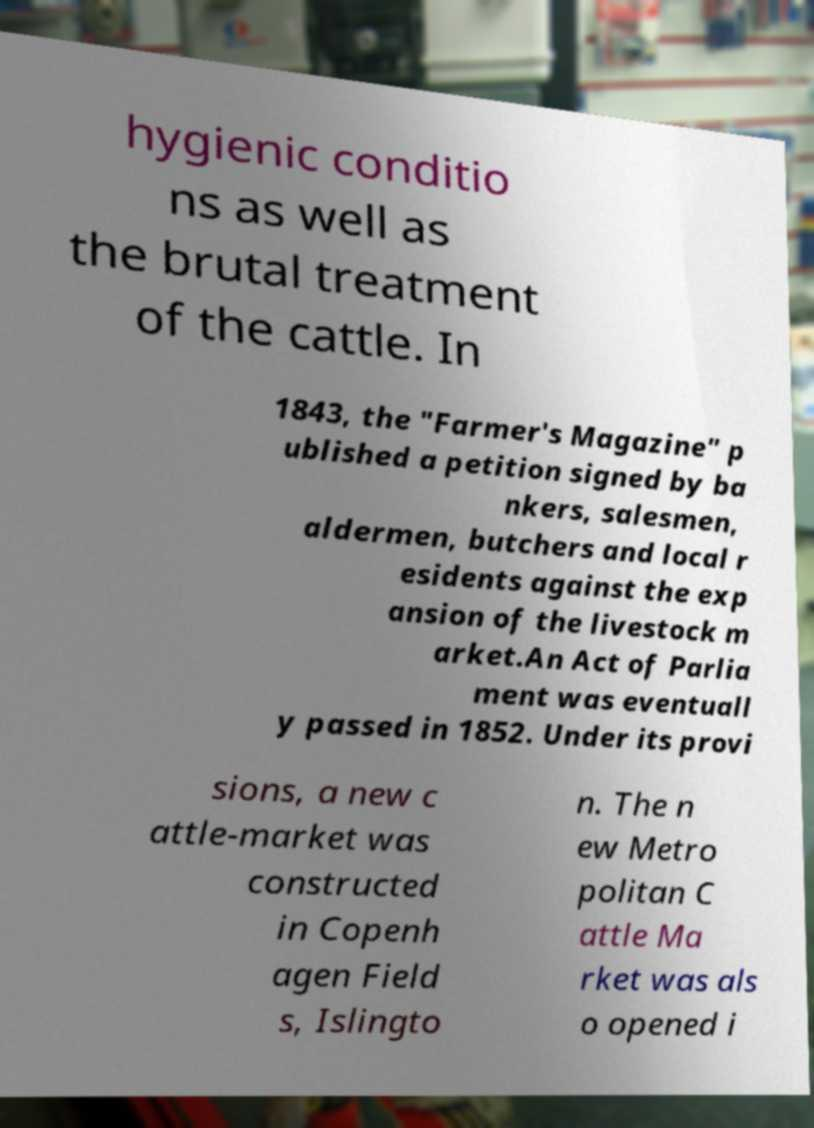I need the written content from this picture converted into text. Can you do that? hygienic conditio ns as well as the brutal treatment of the cattle. In 1843, the "Farmer's Magazine" p ublished a petition signed by ba nkers, salesmen, aldermen, butchers and local r esidents against the exp ansion of the livestock m arket.An Act of Parlia ment was eventuall y passed in 1852. Under its provi sions, a new c attle-market was constructed in Copenh agen Field s, Islingto n. The n ew Metro politan C attle Ma rket was als o opened i 